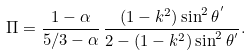<formula> <loc_0><loc_0><loc_500><loc_500>\Pi = \frac { 1 - \alpha } { 5 / 3 - \alpha } \, \frac { ( 1 - k ^ { 2 } ) \sin ^ { 2 } \theta ^ { ^ { \prime } } } { 2 - ( 1 - k ^ { 2 } ) \sin ^ { 2 } \theta ^ { ^ { \prime } } } .</formula> 